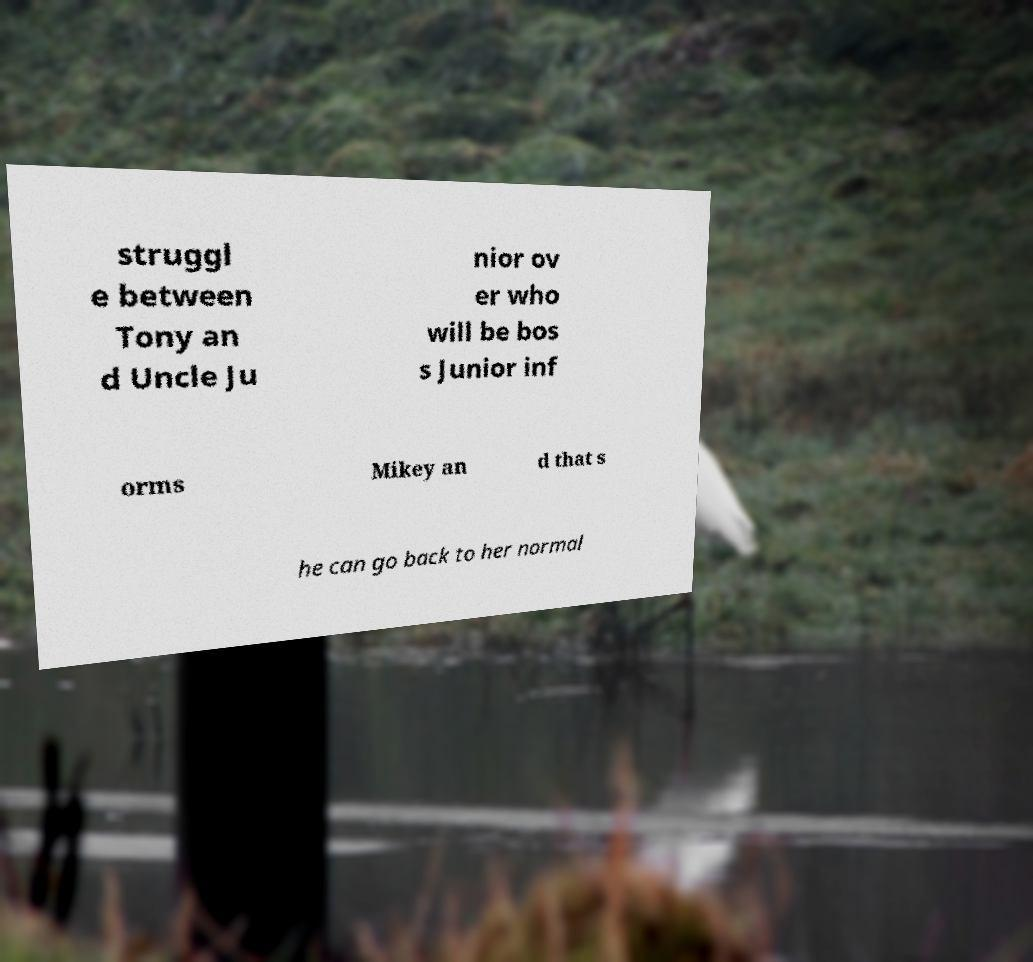Can you accurately transcribe the text from the provided image for me? struggl e between Tony an d Uncle Ju nior ov er who will be bos s Junior inf orms Mikey an d that s he can go back to her normal 